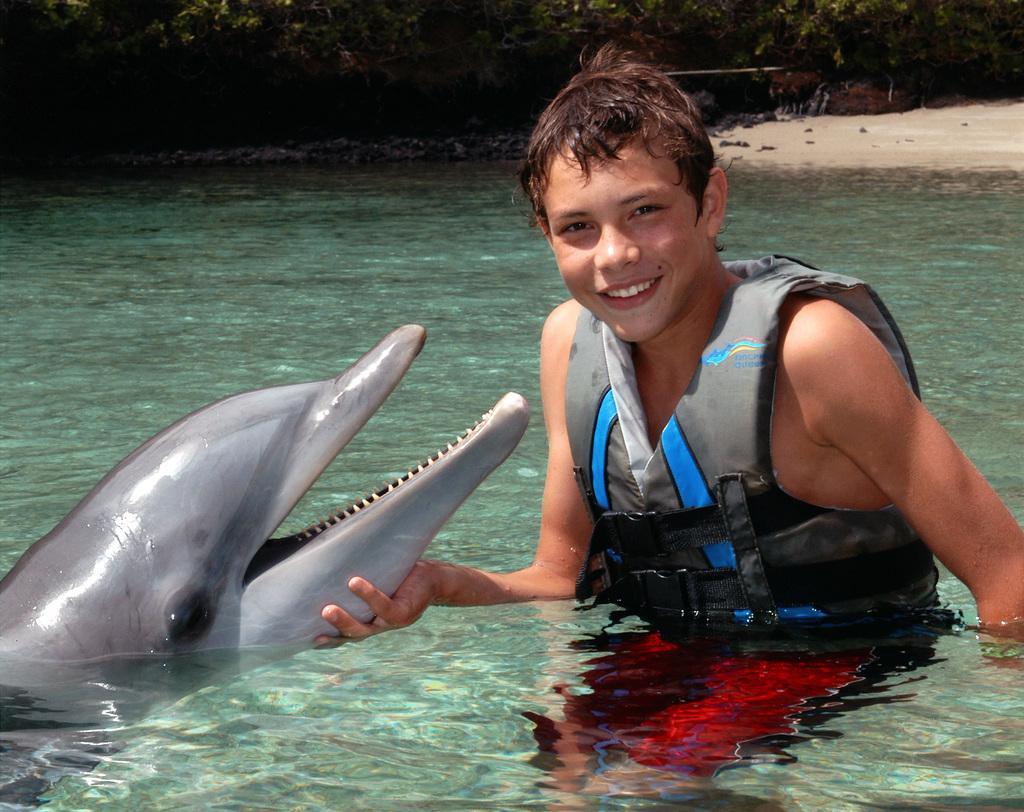How would you summarize this image in a sentence or two? In this image we can see a person wearing a jacket and there is a dolphin. At the bottom of the image there is water. In the background of the image there are trees and sand. 